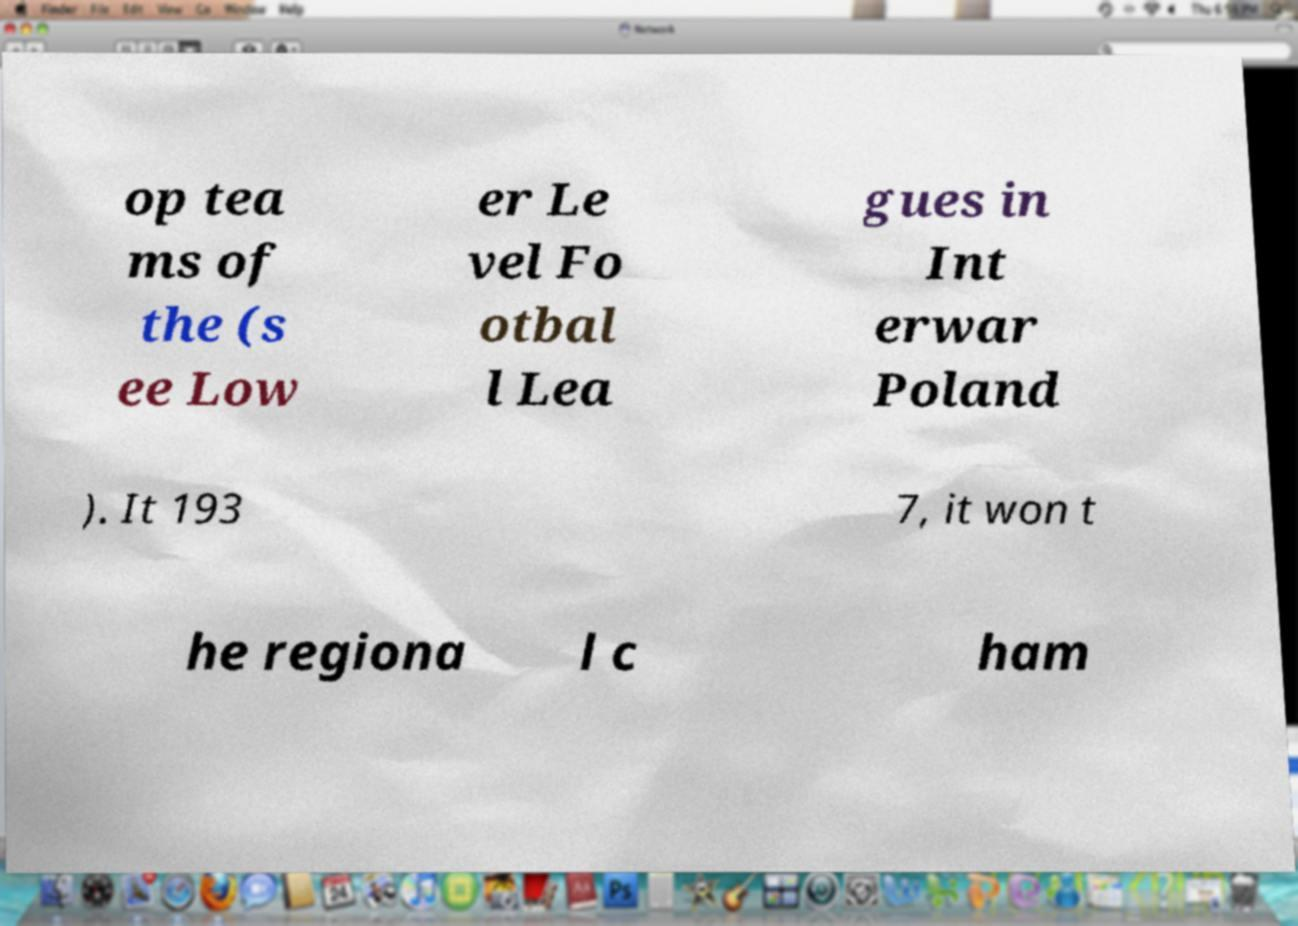Please read and relay the text visible in this image. What does it say? op tea ms of the (s ee Low er Le vel Fo otbal l Lea gues in Int erwar Poland ). It 193 7, it won t he regiona l c ham 